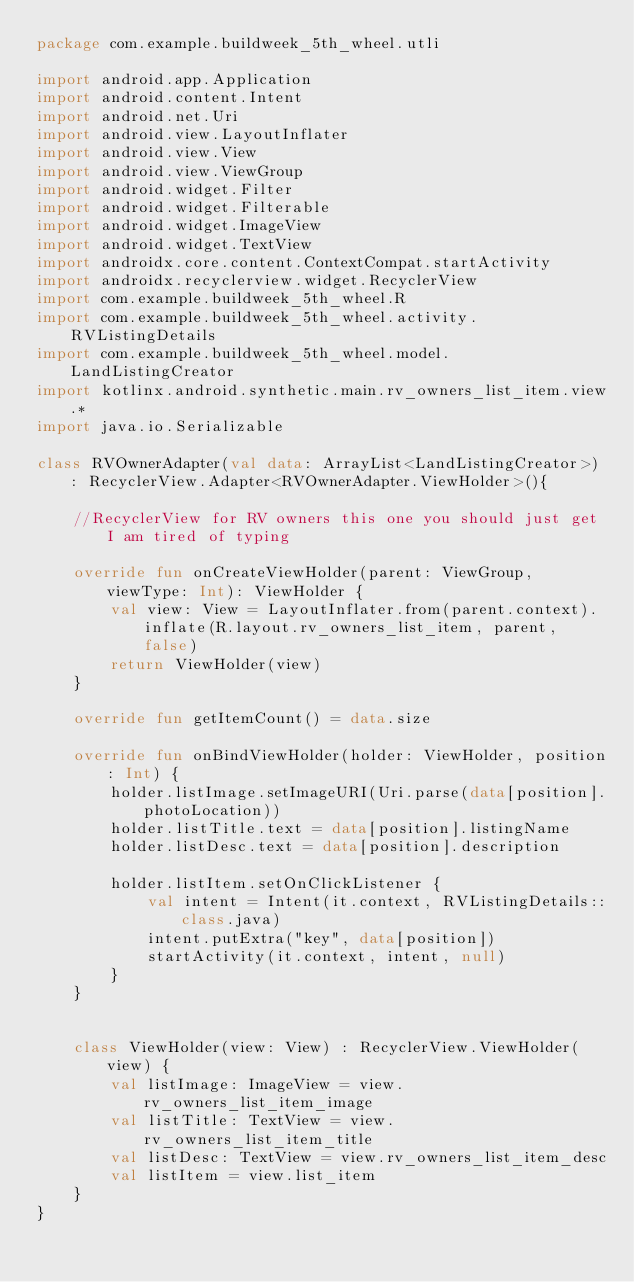Convert code to text. <code><loc_0><loc_0><loc_500><loc_500><_Kotlin_>package com.example.buildweek_5th_wheel.utli

import android.app.Application
import android.content.Intent
import android.net.Uri
import android.view.LayoutInflater
import android.view.View
import android.view.ViewGroup
import android.widget.Filter
import android.widget.Filterable
import android.widget.ImageView
import android.widget.TextView
import androidx.core.content.ContextCompat.startActivity
import androidx.recyclerview.widget.RecyclerView
import com.example.buildweek_5th_wheel.R
import com.example.buildweek_5th_wheel.activity.RVListingDetails
import com.example.buildweek_5th_wheel.model.LandListingCreator
import kotlinx.android.synthetic.main.rv_owners_list_item.view.*
import java.io.Serializable

class RVOwnerAdapter(val data: ArrayList<LandListingCreator>) : RecyclerView.Adapter<RVOwnerAdapter.ViewHolder>(){

    //RecyclerView for RV owners this one you should just get I am tired of typing

    override fun onCreateViewHolder(parent: ViewGroup, viewType: Int): ViewHolder {
        val view: View = LayoutInflater.from(parent.context).inflate(R.layout.rv_owners_list_item, parent, false)
        return ViewHolder(view)
    }

    override fun getItemCount() = data.size

    override fun onBindViewHolder(holder: ViewHolder, position: Int) {
        holder.listImage.setImageURI(Uri.parse(data[position].photoLocation))
        holder.listTitle.text = data[position].listingName
        holder.listDesc.text = data[position].description

        holder.listItem.setOnClickListener {
            val intent = Intent(it.context, RVListingDetails::class.java)
            intent.putExtra("key", data[position])
            startActivity(it.context, intent, null)
        }
    }


    class ViewHolder(view: View) : RecyclerView.ViewHolder(view) {
        val listImage: ImageView = view.rv_owners_list_item_image
        val listTitle: TextView = view.rv_owners_list_item_title
        val listDesc: TextView = view.rv_owners_list_item_desc
        val listItem = view.list_item
    }
}</code> 